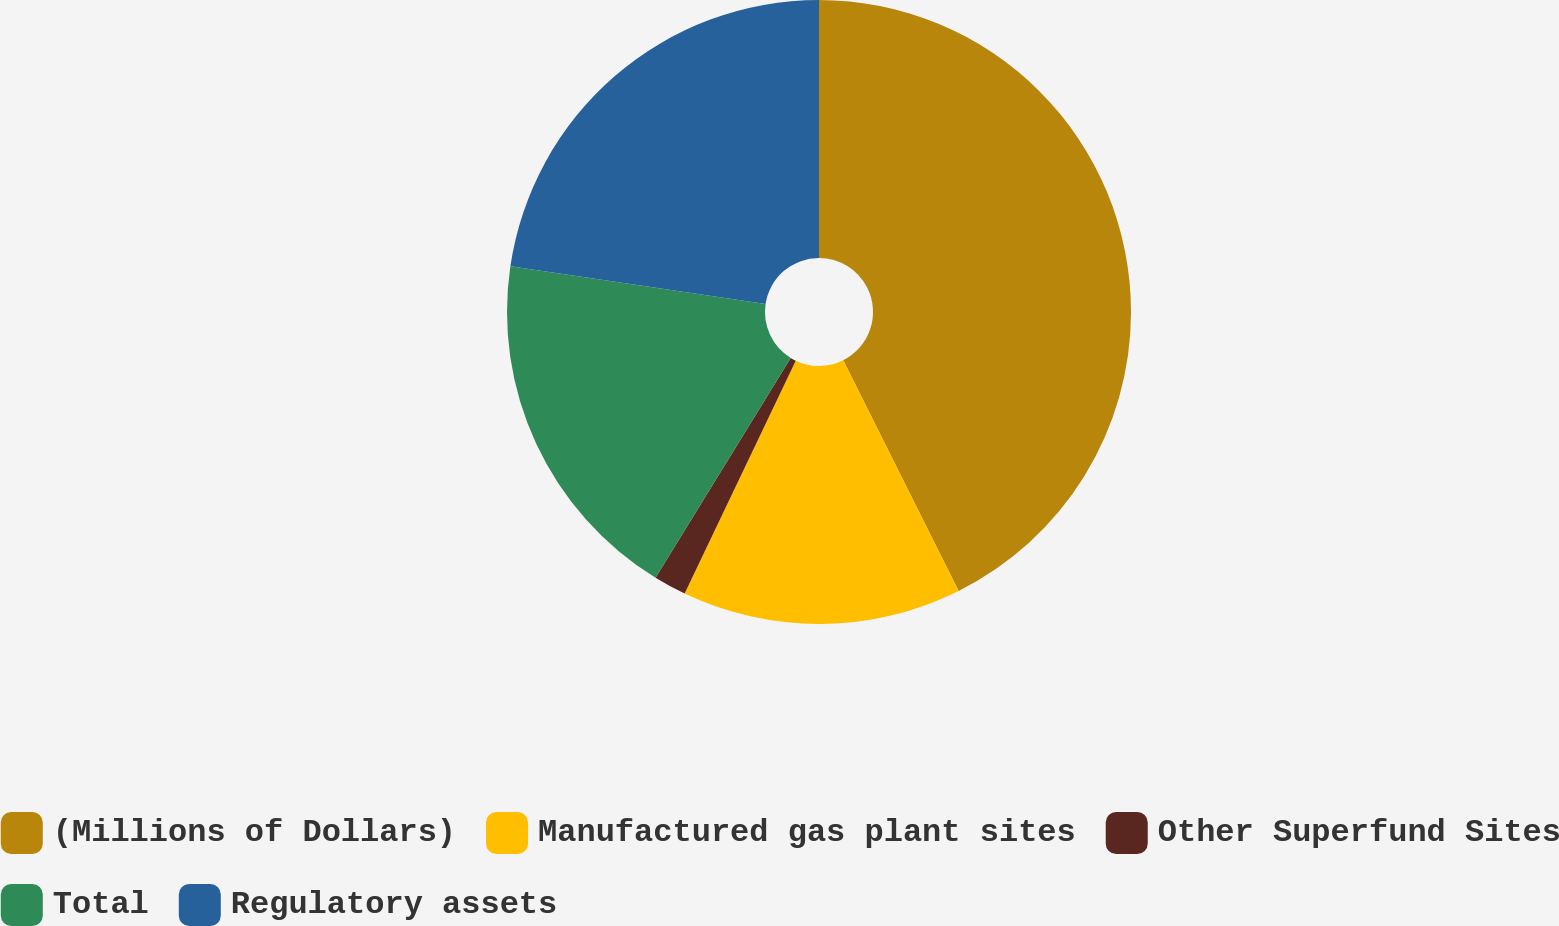Convert chart. <chart><loc_0><loc_0><loc_500><loc_500><pie_chart><fcel>(Millions of Dollars)<fcel>Manufactured gas plant sites<fcel>Other Superfund Sites<fcel>Total<fcel>Regulatory assets<nl><fcel>42.61%<fcel>14.47%<fcel>1.69%<fcel>18.56%<fcel>22.66%<nl></chart> 